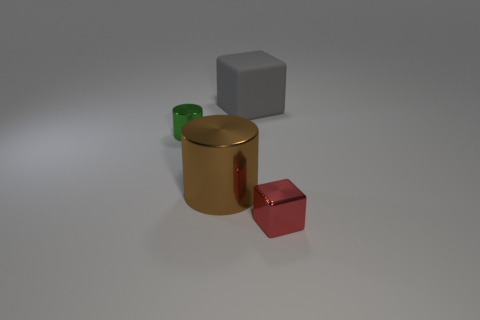Is there any other thing that has the same material as the small red block? Given the appearance of the objects in the image, it looks like the golden cylinder shares a similar reflective material quality with the small red block, suggesting that they might be made of a similar material, such as a type of polished metal. 